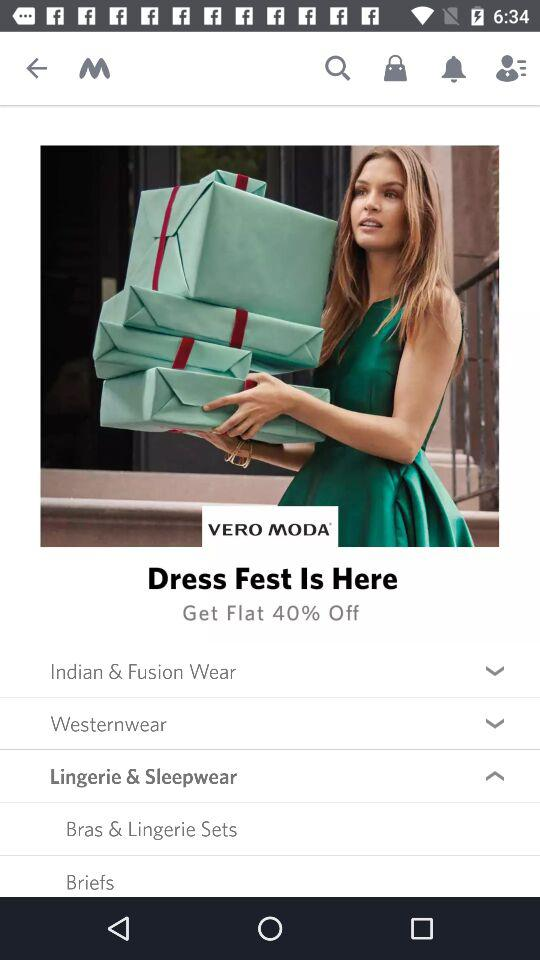Briefs come in which category of clothing? Briefs come in the "Lingerie & Sleepwear" category. 